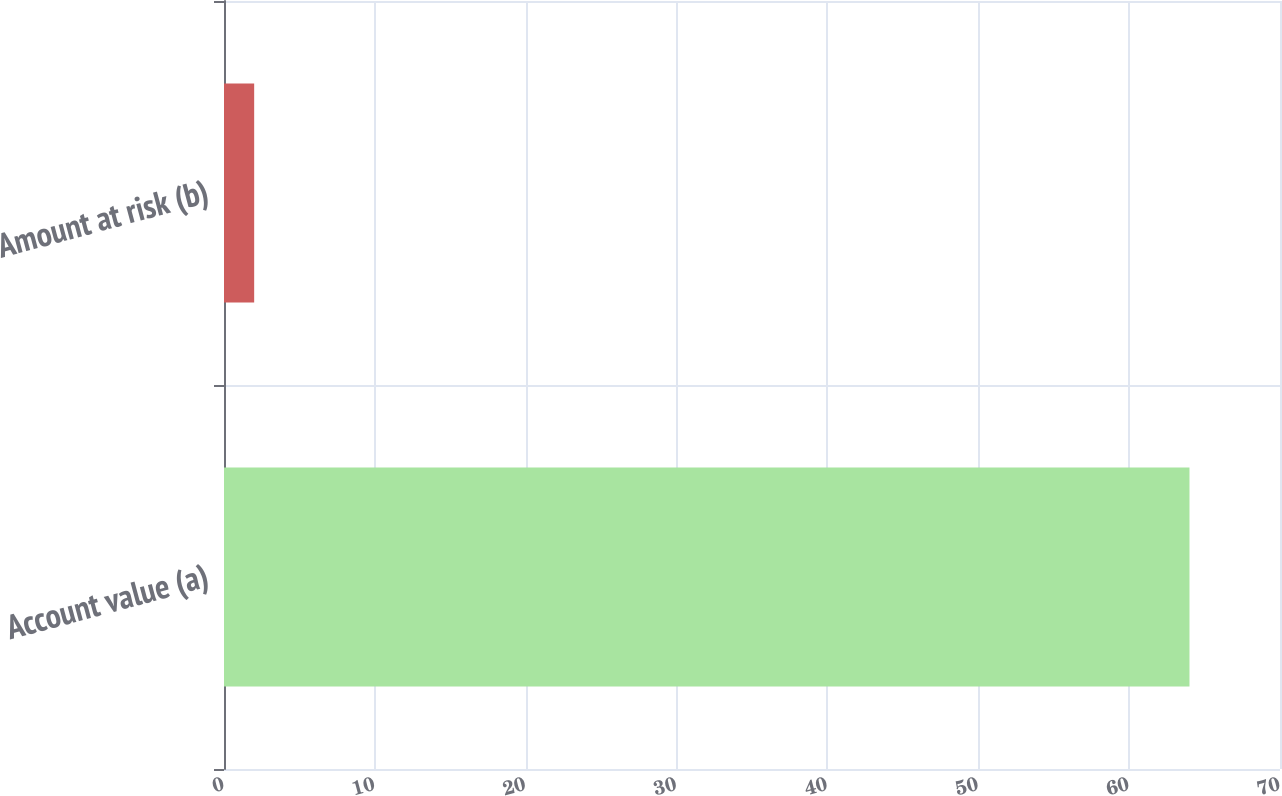<chart> <loc_0><loc_0><loc_500><loc_500><bar_chart><fcel>Account value (a)<fcel>Amount at risk (b)<nl><fcel>64<fcel>2<nl></chart> 